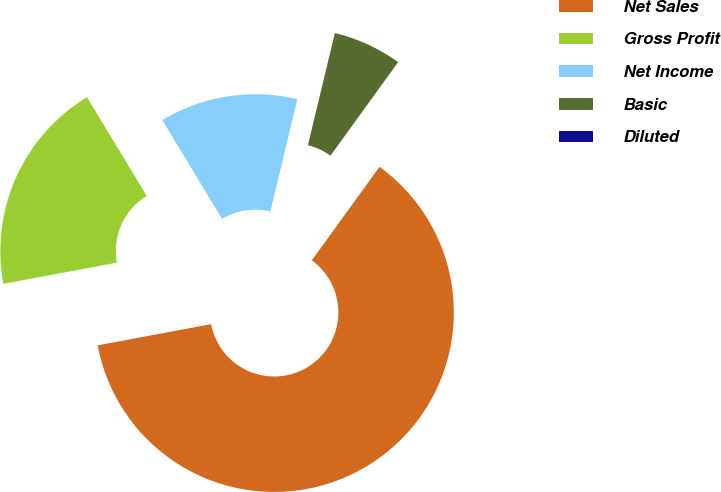<chart> <loc_0><loc_0><loc_500><loc_500><pie_chart><fcel>Net Sales<fcel>Gross Profit<fcel>Net Income<fcel>Basic<fcel>Diluted<nl><fcel>62.09%<fcel>19.28%<fcel>12.42%<fcel>6.21%<fcel>0.0%<nl></chart> 